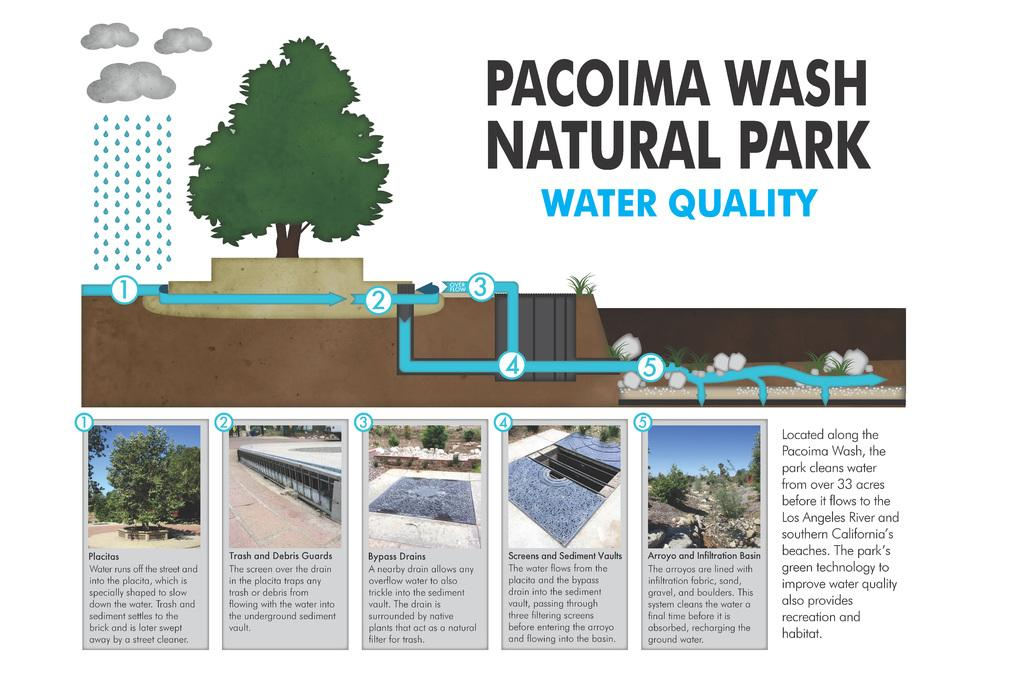What types of images are present in the articles in the image? The pictures depict trees, rocks, plants, and clouds. What natural elements are mentioned in the image? Rain is mentioned in the image. Is there any text present on the articles in the image? Yes, there is a name written on one of the articles. What process does the queen use to print her name on the article? There is no queen present in the image, and the process of printing the name is not mentioned or depicted. 